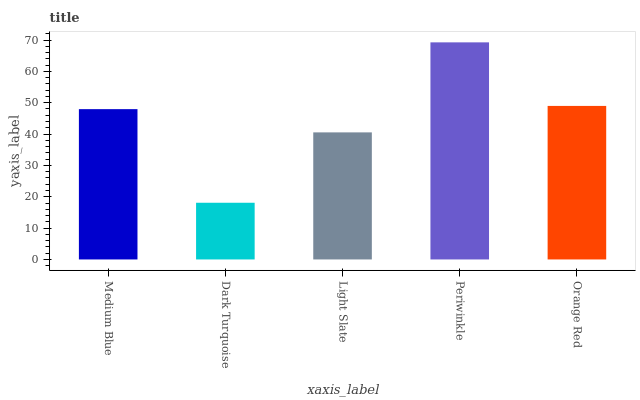Is Dark Turquoise the minimum?
Answer yes or no. Yes. Is Periwinkle the maximum?
Answer yes or no. Yes. Is Light Slate the minimum?
Answer yes or no. No. Is Light Slate the maximum?
Answer yes or no. No. Is Light Slate greater than Dark Turquoise?
Answer yes or no. Yes. Is Dark Turquoise less than Light Slate?
Answer yes or no. Yes. Is Dark Turquoise greater than Light Slate?
Answer yes or no. No. Is Light Slate less than Dark Turquoise?
Answer yes or no. No. Is Medium Blue the high median?
Answer yes or no. Yes. Is Medium Blue the low median?
Answer yes or no. Yes. Is Orange Red the high median?
Answer yes or no. No. Is Periwinkle the low median?
Answer yes or no. No. 